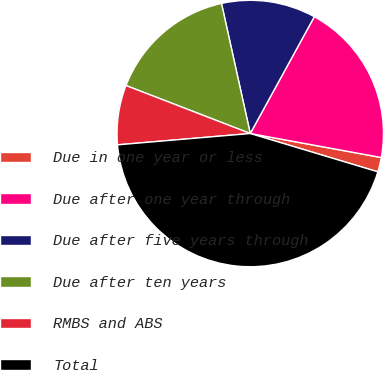Convert chart to OTSL. <chart><loc_0><loc_0><loc_500><loc_500><pie_chart><fcel>Due in one year or less<fcel>Due after one year through<fcel>Due after five years through<fcel>Due after ten years<fcel>RMBS and ABS<fcel>Total<nl><fcel>1.76%<fcel>19.9%<fcel>11.45%<fcel>15.67%<fcel>7.22%<fcel>44.0%<nl></chart> 